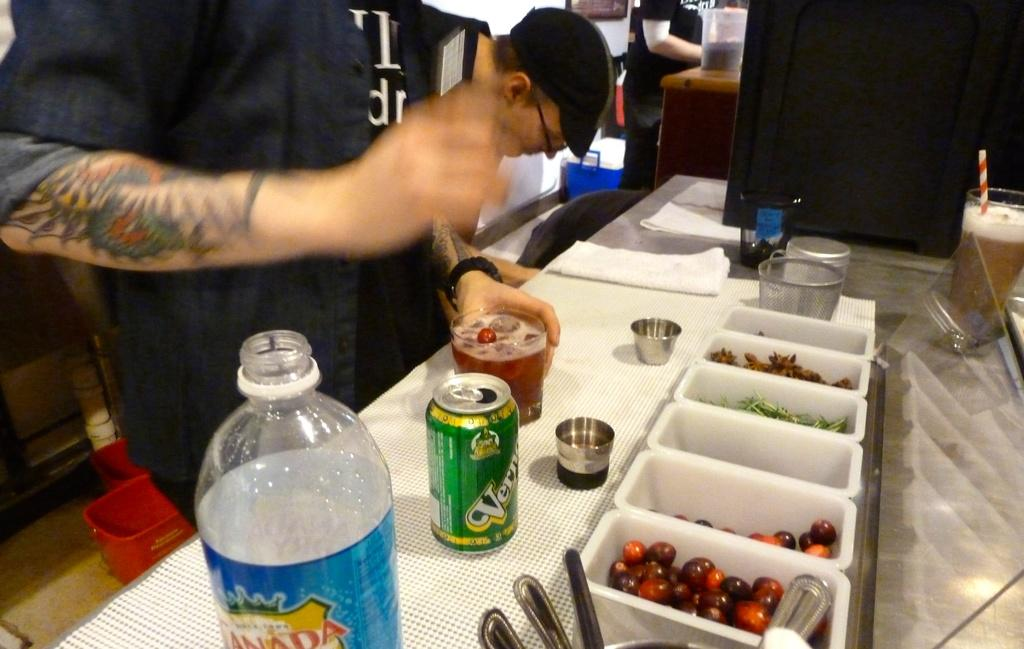What type of container is visible in the image? There is a water bottle in the image. What other type of container can be seen in the image? There is a tin in the image. What is being held in a glass container in the image? There is a glass of drink in the image. What are the small containers used for in the image? There are small cups in the image, which are likely used for drinking. What utensils are present in the image? There are spoons in the image. What type of food is present in small boxes in the image? There are small boxes containing food in the image. Where are these objects located in the image? The objects are on a table. Are there any people nearby in the image? Yes, there are people nearby. Can you see any chickens in the image? There are no chickens present in the image. What type of berry is being served in the small cups in the image? There are no berries mentioned or visible in the image; the small cups contain unspecified food. 